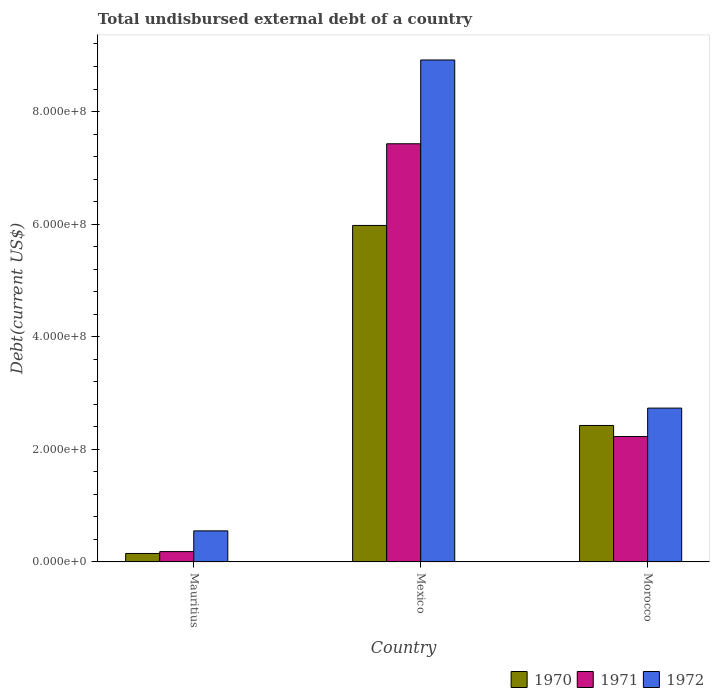How many groups of bars are there?
Provide a succinct answer. 3. Are the number of bars per tick equal to the number of legend labels?
Ensure brevity in your answer.  Yes. Are the number of bars on each tick of the X-axis equal?
Your response must be concise. Yes. How many bars are there on the 1st tick from the left?
Give a very brief answer. 3. What is the label of the 3rd group of bars from the left?
Provide a short and direct response. Morocco. What is the total undisbursed external debt in 1971 in Mexico?
Give a very brief answer. 7.43e+08. Across all countries, what is the maximum total undisbursed external debt in 1972?
Your response must be concise. 8.92e+08. Across all countries, what is the minimum total undisbursed external debt in 1972?
Your answer should be very brief. 5.52e+07. In which country was the total undisbursed external debt in 1971 minimum?
Ensure brevity in your answer.  Mauritius. What is the total total undisbursed external debt in 1972 in the graph?
Provide a succinct answer. 1.22e+09. What is the difference between the total undisbursed external debt in 1971 in Mauritius and that in Mexico?
Provide a succinct answer. -7.24e+08. What is the difference between the total undisbursed external debt in 1972 in Mauritius and the total undisbursed external debt in 1971 in Mexico?
Offer a very short reply. -6.88e+08. What is the average total undisbursed external debt in 1972 per country?
Your answer should be compact. 4.07e+08. What is the difference between the total undisbursed external debt of/in 1970 and total undisbursed external debt of/in 1971 in Mexico?
Ensure brevity in your answer.  -1.45e+08. What is the ratio of the total undisbursed external debt in 1970 in Mexico to that in Morocco?
Offer a terse response. 2.47. What is the difference between the highest and the second highest total undisbursed external debt in 1970?
Give a very brief answer. 5.83e+08. What is the difference between the highest and the lowest total undisbursed external debt in 1972?
Keep it short and to the point. 8.36e+08. What does the 1st bar from the right in Morocco represents?
Your answer should be compact. 1972. Are all the bars in the graph horizontal?
Offer a very short reply. No. Does the graph contain grids?
Give a very brief answer. No. How are the legend labels stacked?
Provide a short and direct response. Horizontal. What is the title of the graph?
Give a very brief answer. Total undisbursed external debt of a country. Does "2012" appear as one of the legend labels in the graph?
Give a very brief answer. No. What is the label or title of the Y-axis?
Give a very brief answer. Debt(current US$). What is the Debt(current US$) of 1970 in Mauritius?
Ensure brevity in your answer.  1.50e+07. What is the Debt(current US$) in 1971 in Mauritius?
Provide a short and direct response. 1.84e+07. What is the Debt(current US$) of 1972 in Mauritius?
Give a very brief answer. 5.52e+07. What is the Debt(current US$) of 1970 in Mexico?
Provide a succinct answer. 5.98e+08. What is the Debt(current US$) in 1971 in Mexico?
Give a very brief answer. 7.43e+08. What is the Debt(current US$) of 1972 in Mexico?
Offer a terse response. 8.92e+08. What is the Debt(current US$) in 1970 in Morocco?
Your answer should be very brief. 2.42e+08. What is the Debt(current US$) of 1971 in Morocco?
Your answer should be very brief. 2.23e+08. What is the Debt(current US$) of 1972 in Morocco?
Provide a succinct answer. 2.73e+08. Across all countries, what is the maximum Debt(current US$) of 1970?
Offer a very short reply. 5.98e+08. Across all countries, what is the maximum Debt(current US$) in 1971?
Provide a succinct answer. 7.43e+08. Across all countries, what is the maximum Debt(current US$) in 1972?
Your response must be concise. 8.92e+08. Across all countries, what is the minimum Debt(current US$) in 1970?
Your response must be concise. 1.50e+07. Across all countries, what is the minimum Debt(current US$) in 1971?
Make the answer very short. 1.84e+07. Across all countries, what is the minimum Debt(current US$) in 1972?
Your answer should be compact. 5.52e+07. What is the total Debt(current US$) in 1970 in the graph?
Your answer should be very brief. 8.55e+08. What is the total Debt(current US$) in 1971 in the graph?
Your answer should be very brief. 9.84e+08. What is the total Debt(current US$) of 1972 in the graph?
Your answer should be compact. 1.22e+09. What is the difference between the Debt(current US$) in 1970 in Mauritius and that in Mexico?
Offer a terse response. -5.83e+08. What is the difference between the Debt(current US$) in 1971 in Mauritius and that in Mexico?
Your response must be concise. -7.24e+08. What is the difference between the Debt(current US$) of 1972 in Mauritius and that in Mexico?
Your response must be concise. -8.36e+08. What is the difference between the Debt(current US$) in 1970 in Mauritius and that in Morocco?
Provide a short and direct response. -2.27e+08. What is the difference between the Debt(current US$) in 1971 in Mauritius and that in Morocco?
Provide a succinct answer. -2.04e+08. What is the difference between the Debt(current US$) in 1972 in Mauritius and that in Morocco?
Ensure brevity in your answer.  -2.18e+08. What is the difference between the Debt(current US$) in 1970 in Mexico and that in Morocco?
Keep it short and to the point. 3.55e+08. What is the difference between the Debt(current US$) of 1971 in Mexico and that in Morocco?
Provide a short and direct response. 5.20e+08. What is the difference between the Debt(current US$) in 1972 in Mexico and that in Morocco?
Make the answer very short. 6.18e+08. What is the difference between the Debt(current US$) in 1970 in Mauritius and the Debt(current US$) in 1971 in Mexico?
Ensure brevity in your answer.  -7.28e+08. What is the difference between the Debt(current US$) of 1970 in Mauritius and the Debt(current US$) of 1972 in Mexico?
Keep it short and to the point. -8.77e+08. What is the difference between the Debt(current US$) of 1971 in Mauritius and the Debt(current US$) of 1972 in Mexico?
Keep it short and to the point. -8.73e+08. What is the difference between the Debt(current US$) of 1970 in Mauritius and the Debt(current US$) of 1971 in Morocco?
Make the answer very short. -2.08e+08. What is the difference between the Debt(current US$) in 1970 in Mauritius and the Debt(current US$) in 1972 in Morocco?
Offer a very short reply. -2.58e+08. What is the difference between the Debt(current US$) in 1971 in Mauritius and the Debt(current US$) in 1972 in Morocco?
Keep it short and to the point. -2.55e+08. What is the difference between the Debt(current US$) of 1970 in Mexico and the Debt(current US$) of 1971 in Morocco?
Make the answer very short. 3.75e+08. What is the difference between the Debt(current US$) of 1970 in Mexico and the Debt(current US$) of 1972 in Morocco?
Your response must be concise. 3.24e+08. What is the difference between the Debt(current US$) of 1971 in Mexico and the Debt(current US$) of 1972 in Morocco?
Offer a very short reply. 4.70e+08. What is the average Debt(current US$) of 1970 per country?
Keep it short and to the point. 2.85e+08. What is the average Debt(current US$) of 1971 per country?
Offer a very short reply. 3.28e+08. What is the average Debt(current US$) of 1972 per country?
Make the answer very short. 4.07e+08. What is the difference between the Debt(current US$) in 1970 and Debt(current US$) in 1971 in Mauritius?
Your response must be concise. -3.32e+06. What is the difference between the Debt(current US$) of 1970 and Debt(current US$) of 1972 in Mauritius?
Your answer should be compact. -4.02e+07. What is the difference between the Debt(current US$) of 1971 and Debt(current US$) of 1972 in Mauritius?
Provide a short and direct response. -3.68e+07. What is the difference between the Debt(current US$) in 1970 and Debt(current US$) in 1971 in Mexico?
Make the answer very short. -1.45e+08. What is the difference between the Debt(current US$) of 1970 and Debt(current US$) of 1972 in Mexico?
Give a very brief answer. -2.94e+08. What is the difference between the Debt(current US$) in 1971 and Debt(current US$) in 1972 in Mexico?
Your answer should be very brief. -1.49e+08. What is the difference between the Debt(current US$) in 1970 and Debt(current US$) in 1971 in Morocco?
Make the answer very short. 1.97e+07. What is the difference between the Debt(current US$) of 1970 and Debt(current US$) of 1972 in Morocco?
Provide a succinct answer. -3.08e+07. What is the difference between the Debt(current US$) in 1971 and Debt(current US$) in 1972 in Morocco?
Your answer should be very brief. -5.05e+07. What is the ratio of the Debt(current US$) of 1970 in Mauritius to that in Mexico?
Provide a short and direct response. 0.03. What is the ratio of the Debt(current US$) of 1971 in Mauritius to that in Mexico?
Offer a terse response. 0.02. What is the ratio of the Debt(current US$) in 1972 in Mauritius to that in Mexico?
Offer a very short reply. 0.06. What is the ratio of the Debt(current US$) of 1970 in Mauritius to that in Morocco?
Your answer should be very brief. 0.06. What is the ratio of the Debt(current US$) in 1971 in Mauritius to that in Morocco?
Offer a very short reply. 0.08. What is the ratio of the Debt(current US$) of 1972 in Mauritius to that in Morocco?
Your answer should be compact. 0.2. What is the ratio of the Debt(current US$) in 1970 in Mexico to that in Morocco?
Provide a short and direct response. 2.47. What is the ratio of the Debt(current US$) in 1971 in Mexico to that in Morocco?
Make the answer very short. 3.33. What is the ratio of the Debt(current US$) in 1972 in Mexico to that in Morocco?
Give a very brief answer. 3.26. What is the difference between the highest and the second highest Debt(current US$) in 1970?
Ensure brevity in your answer.  3.55e+08. What is the difference between the highest and the second highest Debt(current US$) in 1971?
Your response must be concise. 5.20e+08. What is the difference between the highest and the second highest Debt(current US$) in 1972?
Your answer should be very brief. 6.18e+08. What is the difference between the highest and the lowest Debt(current US$) of 1970?
Your answer should be compact. 5.83e+08. What is the difference between the highest and the lowest Debt(current US$) in 1971?
Your response must be concise. 7.24e+08. What is the difference between the highest and the lowest Debt(current US$) of 1972?
Keep it short and to the point. 8.36e+08. 